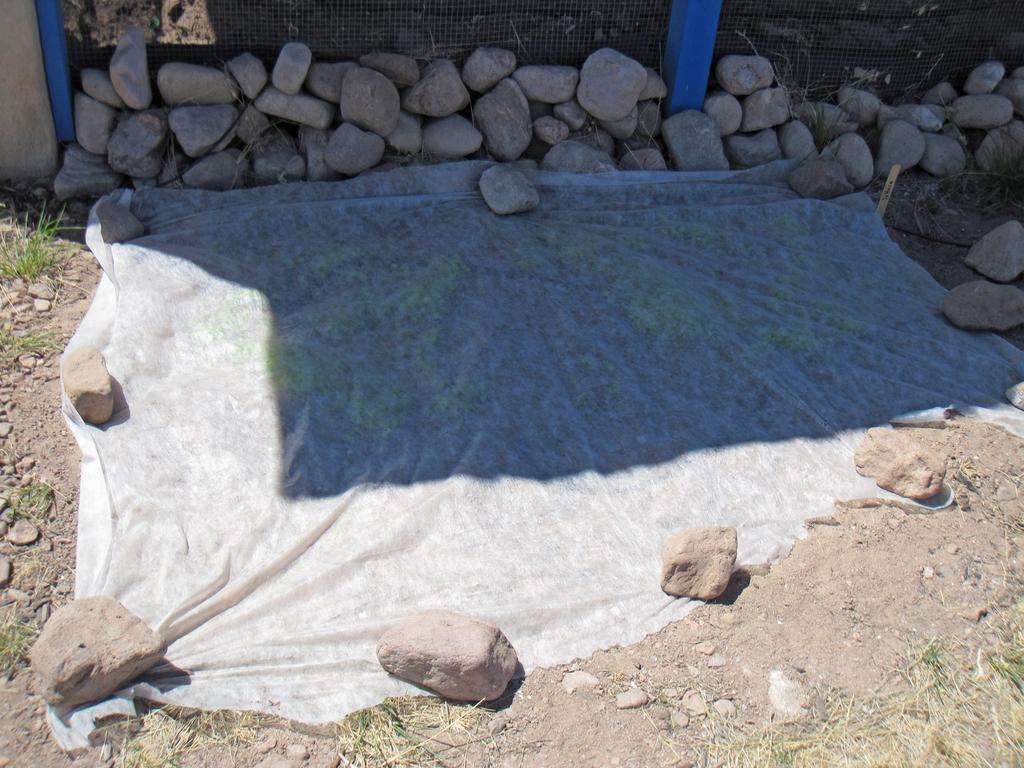Please provide a concise description of this image. In this picture we can see a cloth on the ground, here we can see stones, grass and in the background we can see a fence. 